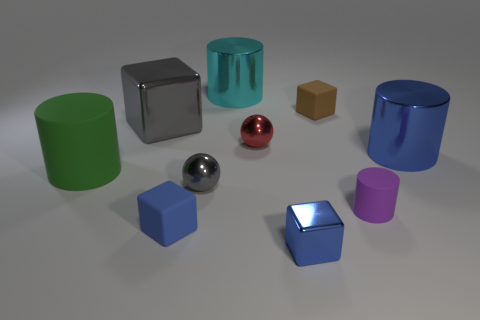Subtract 1 cylinders. How many cylinders are left? 3 Subtract all gray cubes. How many cubes are left? 3 Subtract all blue metallic cubes. How many cubes are left? 3 Subtract all yellow cylinders. Subtract all purple blocks. How many cylinders are left? 4 Subtract all balls. How many objects are left? 8 Add 6 tiny gray things. How many tiny gray things exist? 7 Subtract 1 blue cylinders. How many objects are left? 9 Subtract all big cyan cylinders. Subtract all metal things. How many objects are left? 3 Add 2 blue cylinders. How many blue cylinders are left? 3 